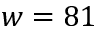Convert formula to latex. <formula><loc_0><loc_0><loc_500><loc_500>w = 8 1</formula> 